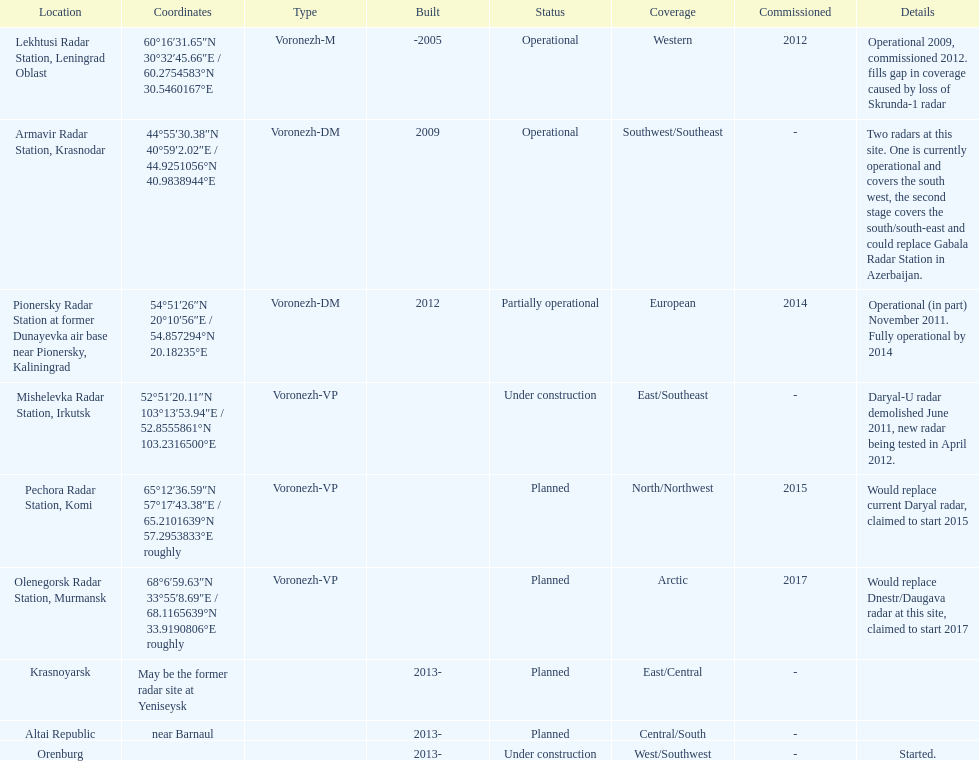What is the total number of locations? 9. 